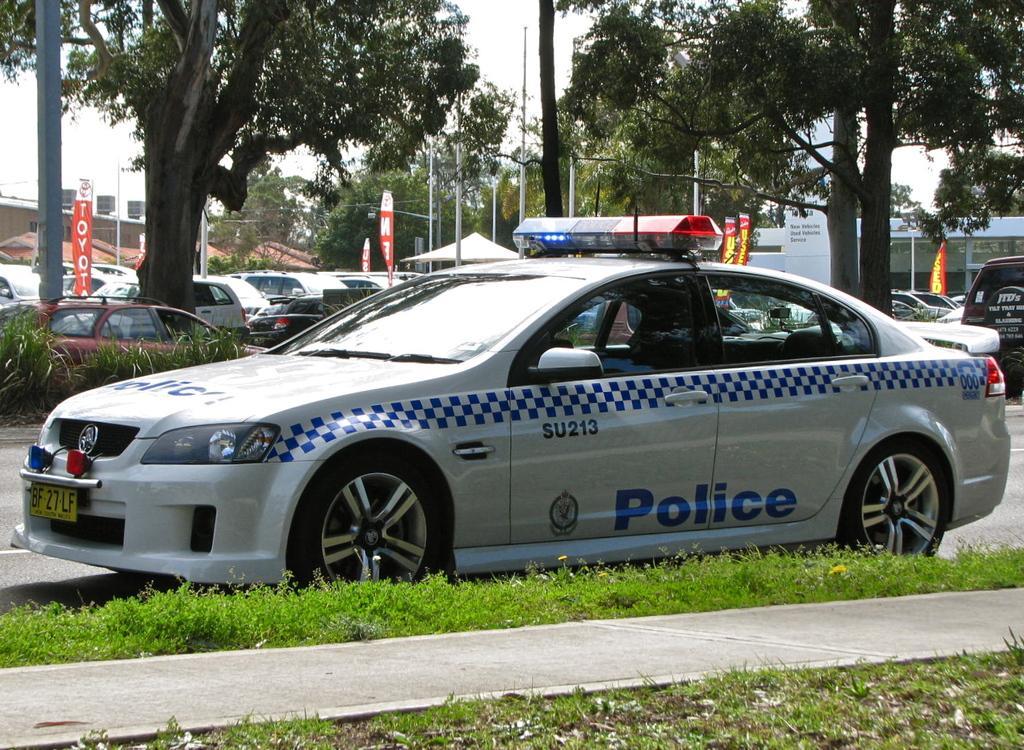In one or two sentences, can you explain what this image depicts? There is a grass at the bottom of this image. We can see trees and cars in the middle of this image and there is a sky in the background. 